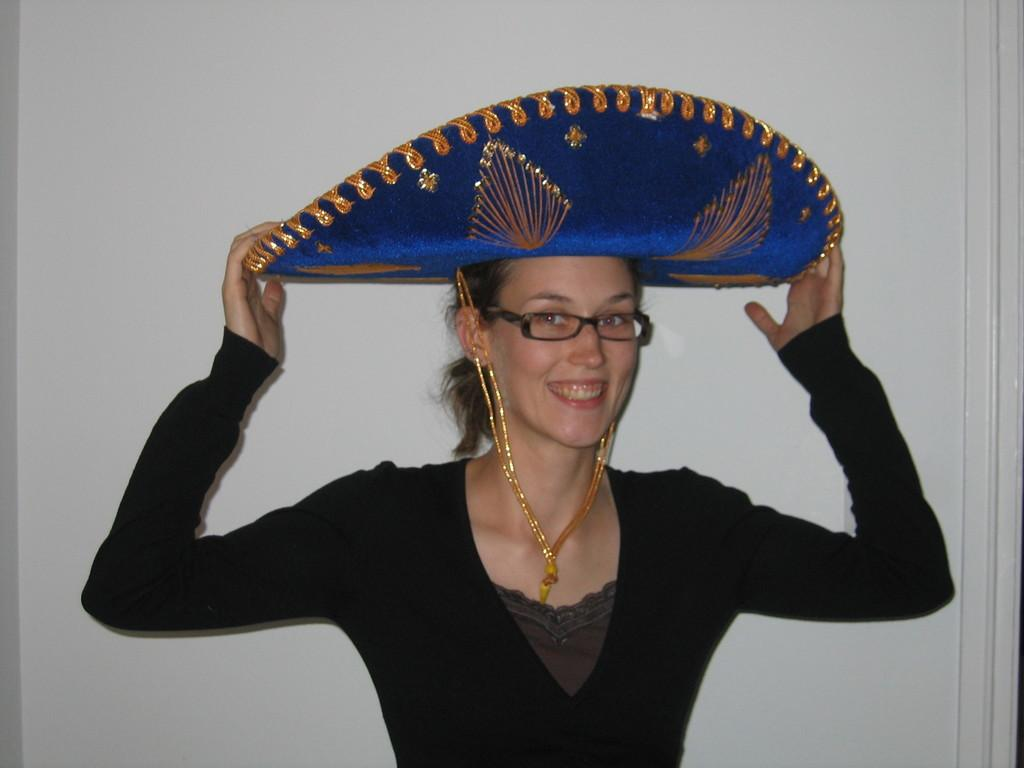Who is the main subject in the image? There is a lady in the center of the image. What is the lady doing in the image? The lady is smiling. What is the lady wearing in the image? The lady is wearing a black dress, a hat, and spectacles. What can be seen in the background of the image? There is a wall in the background of the image. How many rabbits are sitting on the crib in the image? There is no crib or rabbits present in the image. What type of fuel is being used by the lady in the image? There is no mention of any fuel being used by the lady in the image. 